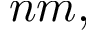Convert formula to latex. <formula><loc_0><loc_0><loc_500><loc_500>n m ,</formula> 